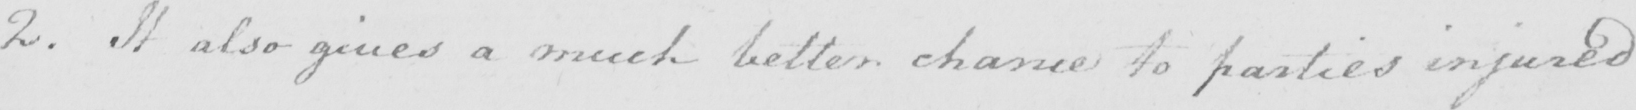What text is written in this handwritten line? 2. It also gives a much better chance to parties injured 